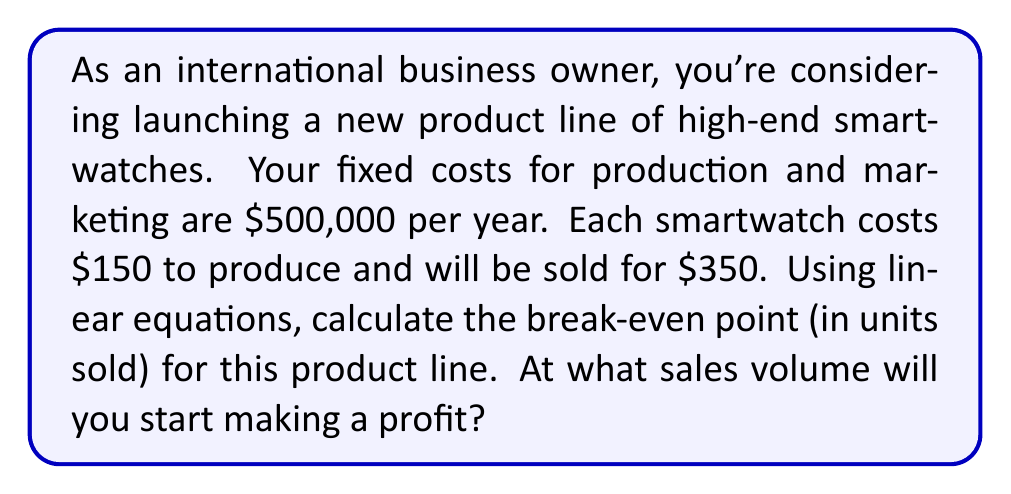Show me your answer to this math problem. To solve this problem, we'll use the break-even formula derived from linear equations:

Let $x$ be the number of units sold
Let $FC$ be the fixed costs
Let $P$ be the price per unit
Let $V$ be the variable cost per unit

The break-even point occurs when Total Revenue equals Total Costs:

$$TR = TC$$
$$Px = FC + Vx$$

Substituting the given values:

$$350x = 500,000 + 150x$$

Now, let's solve for $x$:

$$350x - 150x = 500,000$$
$$200x = 500,000$$
$$x = \frac{500,000}{200}$$
$$x = 2,500$$

To verify, let's check the Total Revenue and Total Costs at this point:

Total Revenue: $350 * 2,500 = 875,000$
Total Costs: $500,000 + (150 * 2,500) = 875,000$

As we can see, at 2,500 units, the Total Revenue equals the Total Costs, confirming our break-even point.
Answer: The break-even point is 2,500 units. You will start making a profit after selling more than 2,500 smartwatches. 